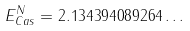<formula> <loc_0><loc_0><loc_500><loc_500>E ^ { N } _ { C a s } = 2 . 1 3 4 3 9 4 0 8 9 2 6 4 \dots</formula> 